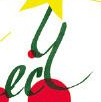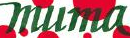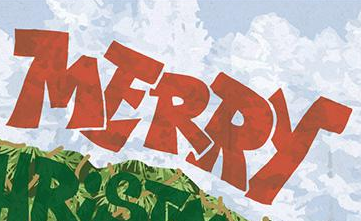Read the text content from these images in order, separated by a semicolon. ecy; muma; MERRY 